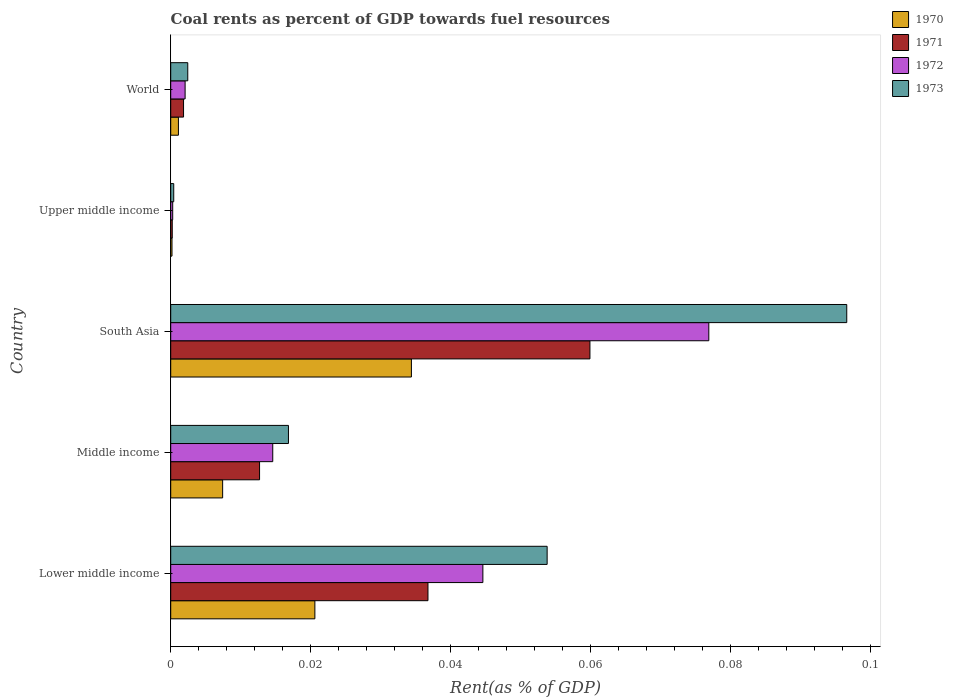How many different coloured bars are there?
Give a very brief answer. 4. Are the number of bars per tick equal to the number of legend labels?
Offer a terse response. Yes. How many bars are there on the 1st tick from the top?
Your answer should be compact. 4. How many bars are there on the 5th tick from the bottom?
Make the answer very short. 4. What is the label of the 2nd group of bars from the top?
Your answer should be compact. Upper middle income. What is the coal rent in 1970 in Upper middle income?
Make the answer very short. 0. Across all countries, what is the maximum coal rent in 1971?
Keep it short and to the point. 0.06. Across all countries, what is the minimum coal rent in 1971?
Provide a short and direct response. 0. In which country was the coal rent in 1972 minimum?
Keep it short and to the point. Upper middle income. What is the total coal rent in 1972 in the graph?
Give a very brief answer. 0.14. What is the difference between the coal rent in 1973 in Upper middle income and that in World?
Provide a short and direct response. -0. What is the difference between the coal rent in 1970 in World and the coal rent in 1971 in Upper middle income?
Keep it short and to the point. 0. What is the average coal rent in 1971 per country?
Your response must be concise. 0.02. What is the difference between the coal rent in 1973 and coal rent in 1970 in World?
Make the answer very short. 0. In how many countries, is the coal rent in 1973 greater than 0.036000000000000004 %?
Offer a very short reply. 2. What is the ratio of the coal rent in 1973 in Upper middle income to that in World?
Provide a short and direct response. 0.18. Is the difference between the coal rent in 1973 in Lower middle income and World greater than the difference between the coal rent in 1970 in Lower middle income and World?
Make the answer very short. Yes. What is the difference between the highest and the second highest coal rent in 1970?
Give a very brief answer. 0.01. What is the difference between the highest and the lowest coal rent in 1973?
Provide a succinct answer. 0.1. Is the sum of the coal rent in 1972 in South Asia and Upper middle income greater than the maximum coal rent in 1971 across all countries?
Provide a short and direct response. Yes. Is it the case that in every country, the sum of the coal rent in 1971 and coal rent in 1973 is greater than the sum of coal rent in 1970 and coal rent in 1972?
Your response must be concise. No. What does the 4th bar from the top in Upper middle income represents?
Ensure brevity in your answer.  1970. Are all the bars in the graph horizontal?
Give a very brief answer. Yes. What is the difference between two consecutive major ticks on the X-axis?
Offer a very short reply. 0.02. Are the values on the major ticks of X-axis written in scientific E-notation?
Provide a short and direct response. No. Does the graph contain any zero values?
Make the answer very short. No. Where does the legend appear in the graph?
Your answer should be very brief. Top right. How are the legend labels stacked?
Keep it short and to the point. Vertical. What is the title of the graph?
Give a very brief answer. Coal rents as percent of GDP towards fuel resources. What is the label or title of the X-axis?
Ensure brevity in your answer.  Rent(as % of GDP). What is the Rent(as % of GDP) of 1970 in Lower middle income?
Make the answer very short. 0.02. What is the Rent(as % of GDP) in 1971 in Lower middle income?
Your response must be concise. 0.04. What is the Rent(as % of GDP) of 1972 in Lower middle income?
Ensure brevity in your answer.  0.04. What is the Rent(as % of GDP) of 1973 in Lower middle income?
Your answer should be very brief. 0.05. What is the Rent(as % of GDP) of 1970 in Middle income?
Ensure brevity in your answer.  0.01. What is the Rent(as % of GDP) of 1971 in Middle income?
Give a very brief answer. 0.01. What is the Rent(as % of GDP) in 1972 in Middle income?
Give a very brief answer. 0.01. What is the Rent(as % of GDP) in 1973 in Middle income?
Your response must be concise. 0.02. What is the Rent(as % of GDP) in 1970 in South Asia?
Offer a very short reply. 0.03. What is the Rent(as % of GDP) of 1971 in South Asia?
Offer a very short reply. 0.06. What is the Rent(as % of GDP) in 1972 in South Asia?
Provide a short and direct response. 0.08. What is the Rent(as % of GDP) of 1973 in South Asia?
Your answer should be compact. 0.1. What is the Rent(as % of GDP) in 1970 in Upper middle income?
Give a very brief answer. 0. What is the Rent(as % of GDP) of 1971 in Upper middle income?
Provide a short and direct response. 0. What is the Rent(as % of GDP) in 1972 in Upper middle income?
Provide a succinct answer. 0. What is the Rent(as % of GDP) in 1973 in Upper middle income?
Provide a succinct answer. 0. What is the Rent(as % of GDP) of 1970 in World?
Ensure brevity in your answer.  0. What is the Rent(as % of GDP) of 1971 in World?
Your answer should be compact. 0. What is the Rent(as % of GDP) of 1972 in World?
Provide a short and direct response. 0. What is the Rent(as % of GDP) of 1973 in World?
Your answer should be compact. 0. Across all countries, what is the maximum Rent(as % of GDP) of 1970?
Give a very brief answer. 0.03. Across all countries, what is the maximum Rent(as % of GDP) of 1971?
Ensure brevity in your answer.  0.06. Across all countries, what is the maximum Rent(as % of GDP) in 1972?
Ensure brevity in your answer.  0.08. Across all countries, what is the maximum Rent(as % of GDP) in 1973?
Make the answer very short. 0.1. Across all countries, what is the minimum Rent(as % of GDP) in 1970?
Ensure brevity in your answer.  0. Across all countries, what is the minimum Rent(as % of GDP) in 1971?
Offer a very short reply. 0. Across all countries, what is the minimum Rent(as % of GDP) in 1972?
Keep it short and to the point. 0. Across all countries, what is the minimum Rent(as % of GDP) in 1973?
Your answer should be very brief. 0. What is the total Rent(as % of GDP) in 1970 in the graph?
Keep it short and to the point. 0.06. What is the total Rent(as % of GDP) of 1971 in the graph?
Offer a very short reply. 0.11. What is the total Rent(as % of GDP) of 1972 in the graph?
Provide a short and direct response. 0.14. What is the total Rent(as % of GDP) of 1973 in the graph?
Your answer should be compact. 0.17. What is the difference between the Rent(as % of GDP) of 1970 in Lower middle income and that in Middle income?
Make the answer very short. 0.01. What is the difference between the Rent(as % of GDP) of 1971 in Lower middle income and that in Middle income?
Provide a short and direct response. 0.02. What is the difference between the Rent(as % of GDP) of 1973 in Lower middle income and that in Middle income?
Make the answer very short. 0.04. What is the difference between the Rent(as % of GDP) in 1970 in Lower middle income and that in South Asia?
Offer a very short reply. -0.01. What is the difference between the Rent(as % of GDP) of 1971 in Lower middle income and that in South Asia?
Offer a terse response. -0.02. What is the difference between the Rent(as % of GDP) of 1972 in Lower middle income and that in South Asia?
Offer a terse response. -0.03. What is the difference between the Rent(as % of GDP) in 1973 in Lower middle income and that in South Asia?
Your answer should be compact. -0.04. What is the difference between the Rent(as % of GDP) in 1970 in Lower middle income and that in Upper middle income?
Give a very brief answer. 0.02. What is the difference between the Rent(as % of GDP) of 1971 in Lower middle income and that in Upper middle income?
Make the answer very short. 0.04. What is the difference between the Rent(as % of GDP) in 1972 in Lower middle income and that in Upper middle income?
Keep it short and to the point. 0.04. What is the difference between the Rent(as % of GDP) in 1973 in Lower middle income and that in Upper middle income?
Make the answer very short. 0.05. What is the difference between the Rent(as % of GDP) of 1970 in Lower middle income and that in World?
Ensure brevity in your answer.  0.02. What is the difference between the Rent(as % of GDP) of 1971 in Lower middle income and that in World?
Provide a short and direct response. 0.03. What is the difference between the Rent(as % of GDP) of 1972 in Lower middle income and that in World?
Your answer should be compact. 0.04. What is the difference between the Rent(as % of GDP) in 1973 in Lower middle income and that in World?
Ensure brevity in your answer.  0.05. What is the difference between the Rent(as % of GDP) of 1970 in Middle income and that in South Asia?
Ensure brevity in your answer.  -0.03. What is the difference between the Rent(as % of GDP) of 1971 in Middle income and that in South Asia?
Make the answer very short. -0.05. What is the difference between the Rent(as % of GDP) of 1972 in Middle income and that in South Asia?
Offer a very short reply. -0.06. What is the difference between the Rent(as % of GDP) of 1973 in Middle income and that in South Asia?
Offer a terse response. -0.08. What is the difference between the Rent(as % of GDP) of 1970 in Middle income and that in Upper middle income?
Your answer should be very brief. 0.01. What is the difference between the Rent(as % of GDP) of 1971 in Middle income and that in Upper middle income?
Make the answer very short. 0.01. What is the difference between the Rent(as % of GDP) in 1972 in Middle income and that in Upper middle income?
Your response must be concise. 0.01. What is the difference between the Rent(as % of GDP) of 1973 in Middle income and that in Upper middle income?
Your response must be concise. 0.02. What is the difference between the Rent(as % of GDP) in 1970 in Middle income and that in World?
Your answer should be very brief. 0.01. What is the difference between the Rent(as % of GDP) in 1971 in Middle income and that in World?
Your response must be concise. 0.01. What is the difference between the Rent(as % of GDP) in 1972 in Middle income and that in World?
Your answer should be compact. 0.01. What is the difference between the Rent(as % of GDP) of 1973 in Middle income and that in World?
Offer a very short reply. 0.01. What is the difference between the Rent(as % of GDP) in 1970 in South Asia and that in Upper middle income?
Give a very brief answer. 0.03. What is the difference between the Rent(as % of GDP) in 1971 in South Asia and that in Upper middle income?
Offer a very short reply. 0.06. What is the difference between the Rent(as % of GDP) in 1972 in South Asia and that in Upper middle income?
Your response must be concise. 0.08. What is the difference between the Rent(as % of GDP) in 1973 in South Asia and that in Upper middle income?
Your answer should be compact. 0.1. What is the difference between the Rent(as % of GDP) in 1971 in South Asia and that in World?
Your response must be concise. 0.06. What is the difference between the Rent(as % of GDP) of 1972 in South Asia and that in World?
Ensure brevity in your answer.  0.07. What is the difference between the Rent(as % of GDP) in 1973 in South Asia and that in World?
Your answer should be very brief. 0.09. What is the difference between the Rent(as % of GDP) of 1970 in Upper middle income and that in World?
Give a very brief answer. -0. What is the difference between the Rent(as % of GDP) in 1971 in Upper middle income and that in World?
Your answer should be very brief. -0. What is the difference between the Rent(as % of GDP) of 1972 in Upper middle income and that in World?
Your answer should be very brief. -0. What is the difference between the Rent(as % of GDP) of 1973 in Upper middle income and that in World?
Provide a succinct answer. -0. What is the difference between the Rent(as % of GDP) in 1970 in Lower middle income and the Rent(as % of GDP) in 1971 in Middle income?
Offer a terse response. 0.01. What is the difference between the Rent(as % of GDP) of 1970 in Lower middle income and the Rent(as % of GDP) of 1972 in Middle income?
Your response must be concise. 0.01. What is the difference between the Rent(as % of GDP) of 1970 in Lower middle income and the Rent(as % of GDP) of 1973 in Middle income?
Offer a terse response. 0. What is the difference between the Rent(as % of GDP) of 1971 in Lower middle income and the Rent(as % of GDP) of 1972 in Middle income?
Offer a very short reply. 0.02. What is the difference between the Rent(as % of GDP) in 1971 in Lower middle income and the Rent(as % of GDP) in 1973 in Middle income?
Provide a short and direct response. 0.02. What is the difference between the Rent(as % of GDP) in 1972 in Lower middle income and the Rent(as % of GDP) in 1973 in Middle income?
Keep it short and to the point. 0.03. What is the difference between the Rent(as % of GDP) in 1970 in Lower middle income and the Rent(as % of GDP) in 1971 in South Asia?
Offer a very short reply. -0.04. What is the difference between the Rent(as % of GDP) in 1970 in Lower middle income and the Rent(as % of GDP) in 1972 in South Asia?
Ensure brevity in your answer.  -0.06. What is the difference between the Rent(as % of GDP) in 1970 in Lower middle income and the Rent(as % of GDP) in 1973 in South Asia?
Offer a terse response. -0.08. What is the difference between the Rent(as % of GDP) in 1971 in Lower middle income and the Rent(as % of GDP) in 1972 in South Asia?
Ensure brevity in your answer.  -0.04. What is the difference between the Rent(as % of GDP) of 1971 in Lower middle income and the Rent(as % of GDP) of 1973 in South Asia?
Make the answer very short. -0.06. What is the difference between the Rent(as % of GDP) of 1972 in Lower middle income and the Rent(as % of GDP) of 1973 in South Asia?
Your answer should be very brief. -0.05. What is the difference between the Rent(as % of GDP) in 1970 in Lower middle income and the Rent(as % of GDP) in 1971 in Upper middle income?
Make the answer very short. 0.02. What is the difference between the Rent(as % of GDP) of 1970 in Lower middle income and the Rent(as % of GDP) of 1972 in Upper middle income?
Ensure brevity in your answer.  0.02. What is the difference between the Rent(as % of GDP) of 1970 in Lower middle income and the Rent(as % of GDP) of 1973 in Upper middle income?
Your answer should be very brief. 0.02. What is the difference between the Rent(as % of GDP) of 1971 in Lower middle income and the Rent(as % of GDP) of 1972 in Upper middle income?
Provide a short and direct response. 0.04. What is the difference between the Rent(as % of GDP) in 1971 in Lower middle income and the Rent(as % of GDP) in 1973 in Upper middle income?
Offer a very short reply. 0.04. What is the difference between the Rent(as % of GDP) of 1972 in Lower middle income and the Rent(as % of GDP) of 1973 in Upper middle income?
Offer a very short reply. 0.04. What is the difference between the Rent(as % of GDP) in 1970 in Lower middle income and the Rent(as % of GDP) in 1971 in World?
Provide a short and direct response. 0.02. What is the difference between the Rent(as % of GDP) in 1970 in Lower middle income and the Rent(as % of GDP) in 1972 in World?
Your response must be concise. 0.02. What is the difference between the Rent(as % of GDP) of 1970 in Lower middle income and the Rent(as % of GDP) of 1973 in World?
Your response must be concise. 0.02. What is the difference between the Rent(as % of GDP) of 1971 in Lower middle income and the Rent(as % of GDP) of 1972 in World?
Provide a succinct answer. 0.03. What is the difference between the Rent(as % of GDP) of 1971 in Lower middle income and the Rent(as % of GDP) of 1973 in World?
Your response must be concise. 0.03. What is the difference between the Rent(as % of GDP) in 1972 in Lower middle income and the Rent(as % of GDP) in 1973 in World?
Provide a short and direct response. 0.04. What is the difference between the Rent(as % of GDP) of 1970 in Middle income and the Rent(as % of GDP) of 1971 in South Asia?
Offer a terse response. -0.05. What is the difference between the Rent(as % of GDP) in 1970 in Middle income and the Rent(as % of GDP) in 1972 in South Asia?
Your answer should be compact. -0.07. What is the difference between the Rent(as % of GDP) of 1970 in Middle income and the Rent(as % of GDP) of 1973 in South Asia?
Your answer should be very brief. -0.09. What is the difference between the Rent(as % of GDP) in 1971 in Middle income and the Rent(as % of GDP) in 1972 in South Asia?
Your answer should be compact. -0.06. What is the difference between the Rent(as % of GDP) of 1971 in Middle income and the Rent(as % of GDP) of 1973 in South Asia?
Your answer should be compact. -0.08. What is the difference between the Rent(as % of GDP) of 1972 in Middle income and the Rent(as % of GDP) of 1973 in South Asia?
Make the answer very short. -0.08. What is the difference between the Rent(as % of GDP) of 1970 in Middle income and the Rent(as % of GDP) of 1971 in Upper middle income?
Your answer should be very brief. 0.01. What is the difference between the Rent(as % of GDP) of 1970 in Middle income and the Rent(as % of GDP) of 1972 in Upper middle income?
Keep it short and to the point. 0.01. What is the difference between the Rent(as % of GDP) of 1970 in Middle income and the Rent(as % of GDP) of 1973 in Upper middle income?
Your answer should be compact. 0.01. What is the difference between the Rent(as % of GDP) of 1971 in Middle income and the Rent(as % of GDP) of 1972 in Upper middle income?
Offer a terse response. 0.01. What is the difference between the Rent(as % of GDP) in 1971 in Middle income and the Rent(as % of GDP) in 1973 in Upper middle income?
Your response must be concise. 0.01. What is the difference between the Rent(as % of GDP) of 1972 in Middle income and the Rent(as % of GDP) of 1973 in Upper middle income?
Your answer should be very brief. 0.01. What is the difference between the Rent(as % of GDP) in 1970 in Middle income and the Rent(as % of GDP) in 1971 in World?
Keep it short and to the point. 0.01. What is the difference between the Rent(as % of GDP) in 1970 in Middle income and the Rent(as % of GDP) in 1972 in World?
Your response must be concise. 0.01. What is the difference between the Rent(as % of GDP) of 1970 in Middle income and the Rent(as % of GDP) of 1973 in World?
Ensure brevity in your answer.  0.01. What is the difference between the Rent(as % of GDP) of 1971 in Middle income and the Rent(as % of GDP) of 1972 in World?
Your answer should be very brief. 0.01. What is the difference between the Rent(as % of GDP) in 1971 in Middle income and the Rent(as % of GDP) in 1973 in World?
Your answer should be compact. 0.01. What is the difference between the Rent(as % of GDP) of 1972 in Middle income and the Rent(as % of GDP) of 1973 in World?
Your answer should be compact. 0.01. What is the difference between the Rent(as % of GDP) in 1970 in South Asia and the Rent(as % of GDP) in 1971 in Upper middle income?
Your response must be concise. 0.03. What is the difference between the Rent(as % of GDP) in 1970 in South Asia and the Rent(as % of GDP) in 1972 in Upper middle income?
Offer a very short reply. 0.03. What is the difference between the Rent(as % of GDP) of 1970 in South Asia and the Rent(as % of GDP) of 1973 in Upper middle income?
Make the answer very short. 0.03. What is the difference between the Rent(as % of GDP) in 1971 in South Asia and the Rent(as % of GDP) in 1972 in Upper middle income?
Offer a terse response. 0.06. What is the difference between the Rent(as % of GDP) in 1971 in South Asia and the Rent(as % of GDP) in 1973 in Upper middle income?
Make the answer very short. 0.06. What is the difference between the Rent(as % of GDP) of 1972 in South Asia and the Rent(as % of GDP) of 1973 in Upper middle income?
Offer a terse response. 0.08. What is the difference between the Rent(as % of GDP) in 1970 in South Asia and the Rent(as % of GDP) in 1971 in World?
Keep it short and to the point. 0.03. What is the difference between the Rent(as % of GDP) of 1970 in South Asia and the Rent(as % of GDP) of 1972 in World?
Offer a very short reply. 0.03. What is the difference between the Rent(as % of GDP) in 1970 in South Asia and the Rent(as % of GDP) in 1973 in World?
Your response must be concise. 0.03. What is the difference between the Rent(as % of GDP) in 1971 in South Asia and the Rent(as % of GDP) in 1972 in World?
Make the answer very short. 0.06. What is the difference between the Rent(as % of GDP) in 1971 in South Asia and the Rent(as % of GDP) in 1973 in World?
Offer a terse response. 0.06. What is the difference between the Rent(as % of GDP) of 1972 in South Asia and the Rent(as % of GDP) of 1973 in World?
Your response must be concise. 0.07. What is the difference between the Rent(as % of GDP) in 1970 in Upper middle income and the Rent(as % of GDP) in 1971 in World?
Your response must be concise. -0. What is the difference between the Rent(as % of GDP) of 1970 in Upper middle income and the Rent(as % of GDP) of 1972 in World?
Keep it short and to the point. -0. What is the difference between the Rent(as % of GDP) of 1970 in Upper middle income and the Rent(as % of GDP) of 1973 in World?
Your answer should be compact. -0. What is the difference between the Rent(as % of GDP) of 1971 in Upper middle income and the Rent(as % of GDP) of 1972 in World?
Provide a succinct answer. -0. What is the difference between the Rent(as % of GDP) in 1971 in Upper middle income and the Rent(as % of GDP) in 1973 in World?
Provide a succinct answer. -0. What is the difference between the Rent(as % of GDP) of 1972 in Upper middle income and the Rent(as % of GDP) of 1973 in World?
Give a very brief answer. -0. What is the average Rent(as % of GDP) in 1970 per country?
Keep it short and to the point. 0.01. What is the average Rent(as % of GDP) of 1971 per country?
Provide a succinct answer. 0.02. What is the average Rent(as % of GDP) of 1972 per country?
Offer a terse response. 0.03. What is the average Rent(as % of GDP) in 1973 per country?
Make the answer very short. 0.03. What is the difference between the Rent(as % of GDP) in 1970 and Rent(as % of GDP) in 1971 in Lower middle income?
Your response must be concise. -0.02. What is the difference between the Rent(as % of GDP) of 1970 and Rent(as % of GDP) of 1972 in Lower middle income?
Offer a very short reply. -0.02. What is the difference between the Rent(as % of GDP) of 1970 and Rent(as % of GDP) of 1973 in Lower middle income?
Provide a short and direct response. -0.03. What is the difference between the Rent(as % of GDP) of 1971 and Rent(as % of GDP) of 1972 in Lower middle income?
Your response must be concise. -0.01. What is the difference between the Rent(as % of GDP) in 1971 and Rent(as % of GDP) in 1973 in Lower middle income?
Give a very brief answer. -0.02. What is the difference between the Rent(as % of GDP) of 1972 and Rent(as % of GDP) of 1973 in Lower middle income?
Offer a terse response. -0.01. What is the difference between the Rent(as % of GDP) of 1970 and Rent(as % of GDP) of 1971 in Middle income?
Provide a succinct answer. -0.01. What is the difference between the Rent(as % of GDP) of 1970 and Rent(as % of GDP) of 1972 in Middle income?
Keep it short and to the point. -0.01. What is the difference between the Rent(as % of GDP) of 1970 and Rent(as % of GDP) of 1973 in Middle income?
Give a very brief answer. -0.01. What is the difference between the Rent(as % of GDP) in 1971 and Rent(as % of GDP) in 1972 in Middle income?
Offer a terse response. -0. What is the difference between the Rent(as % of GDP) in 1971 and Rent(as % of GDP) in 1973 in Middle income?
Your response must be concise. -0. What is the difference between the Rent(as % of GDP) of 1972 and Rent(as % of GDP) of 1973 in Middle income?
Ensure brevity in your answer.  -0. What is the difference between the Rent(as % of GDP) of 1970 and Rent(as % of GDP) of 1971 in South Asia?
Offer a terse response. -0.03. What is the difference between the Rent(as % of GDP) in 1970 and Rent(as % of GDP) in 1972 in South Asia?
Your answer should be compact. -0.04. What is the difference between the Rent(as % of GDP) of 1970 and Rent(as % of GDP) of 1973 in South Asia?
Provide a short and direct response. -0.06. What is the difference between the Rent(as % of GDP) of 1971 and Rent(as % of GDP) of 1972 in South Asia?
Give a very brief answer. -0.02. What is the difference between the Rent(as % of GDP) in 1971 and Rent(as % of GDP) in 1973 in South Asia?
Give a very brief answer. -0.04. What is the difference between the Rent(as % of GDP) in 1972 and Rent(as % of GDP) in 1973 in South Asia?
Ensure brevity in your answer.  -0.02. What is the difference between the Rent(as % of GDP) of 1970 and Rent(as % of GDP) of 1972 in Upper middle income?
Provide a succinct answer. -0. What is the difference between the Rent(as % of GDP) in 1970 and Rent(as % of GDP) in 1973 in Upper middle income?
Your answer should be very brief. -0. What is the difference between the Rent(as % of GDP) in 1971 and Rent(as % of GDP) in 1972 in Upper middle income?
Keep it short and to the point. -0. What is the difference between the Rent(as % of GDP) in 1971 and Rent(as % of GDP) in 1973 in Upper middle income?
Provide a short and direct response. -0. What is the difference between the Rent(as % of GDP) of 1972 and Rent(as % of GDP) of 1973 in Upper middle income?
Your response must be concise. -0. What is the difference between the Rent(as % of GDP) of 1970 and Rent(as % of GDP) of 1971 in World?
Provide a short and direct response. -0. What is the difference between the Rent(as % of GDP) of 1970 and Rent(as % of GDP) of 1972 in World?
Provide a succinct answer. -0. What is the difference between the Rent(as % of GDP) of 1970 and Rent(as % of GDP) of 1973 in World?
Offer a very short reply. -0. What is the difference between the Rent(as % of GDP) in 1971 and Rent(as % of GDP) in 1972 in World?
Provide a short and direct response. -0. What is the difference between the Rent(as % of GDP) of 1971 and Rent(as % of GDP) of 1973 in World?
Make the answer very short. -0. What is the difference between the Rent(as % of GDP) in 1972 and Rent(as % of GDP) in 1973 in World?
Offer a very short reply. -0. What is the ratio of the Rent(as % of GDP) of 1970 in Lower middle income to that in Middle income?
Your response must be concise. 2.78. What is the ratio of the Rent(as % of GDP) of 1971 in Lower middle income to that in Middle income?
Provide a succinct answer. 2.9. What is the ratio of the Rent(as % of GDP) of 1972 in Lower middle income to that in Middle income?
Provide a short and direct response. 3.06. What is the ratio of the Rent(as % of GDP) of 1973 in Lower middle income to that in Middle income?
Keep it short and to the point. 3.2. What is the ratio of the Rent(as % of GDP) of 1970 in Lower middle income to that in South Asia?
Give a very brief answer. 0.6. What is the ratio of the Rent(as % of GDP) of 1971 in Lower middle income to that in South Asia?
Keep it short and to the point. 0.61. What is the ratio of the Rent(as % of GDP) in 1972 in Lower middle income to that in South Asia?
Offer a very short reply. 0.58. What is the ratio of the Rent(as % of GDP) in 1973 in Lower middle income to that in South Asia?
Provide a succinct answer. 0.56. What is the ratio of the Rent(as % of GDP) in 1970 in Lower middle income to that in Upper middle income?
Your answer should be compact. 112.03. What is the ratio of the Rent(as % of GDP) in 1971 in Lower middle income to that in Upper middle income?
Make the answer very short. 167.98. What is the ratio of the Rent(as % of GDP) of 1972 in Lower middle income to that in Upper middle income?
Keep it short and to the point. 156.82. What is the ratio of the Rent(as % of GDP) of 1973 in Lower middle income to that in Upper middle income?
Ensure brevity in your answer.  124.82. What is the ratio of the Rent(as % of GDP) of 1970 in Lower middle income to that in World?
Your answer should be very brief. 18.71. What is the ratio of the Rent(as % of GDP) of 1971 in Lower middle income to that in World?
Provide a succinct answer. 20.06. What is the ratio of the Rent(as % of GDP) in 1972 in Lower middle income to that in World?
Make the answer very short. 21.7. What is the ratio of the Rent(as % of GDP) of 1973 in Lower middle income to that in World?
Offer a terse response. 22.07. What is the ratio of the Rent(as % of GDP) in 1970 in Middle income to that in South Asia?
Give a very brief answer. 0.22. What is the ratio of the Rent(as % of GDP) in 1971 in Middle income to that in South Asia?
Offer a very short reply. 0.21. What is the ratio of the Rent(as % of GDP) in 1972 in Middle income to that in South Asia?
Offer a very short reply. 0.19. What is the ratio of the Rent(as % of GDP) in 1973 in Middle income to that in South Asia?
Your answer should be compact. 0.17. What is the ratio of the Rent(as % of GDP) in 1970 in Middle income to that in Upper middle income?
Provide a short and direct response. 40.36. What is the ratio of the Rent(as % of GDP) in 1971 in Middle income to that in Upper middle income?
Your answer should be very brief. 58.01. What is the ratio of the Rent(as % of GDP) of 1972 in Middle income to that in Upper middle income?
Offer a very short reply. 51.25. What is the ratio of the Rent(as % of GDP) of 1973 in Middle income to that in Upper middle income?
Your answer should be very brief. 39.04. What is the ratio of the Rent(as % of GDP) in 1970 in Middle income to that in World?
Your answer should be compact. 6.74. What is the ratio of the Rent(as % of GDP) in 1971 in Middle income to that in World?
Give a very brief answer. 6.93. What is the ratio of the Rent(as % of GDP) of 1972 in Middle income to that in World?
Make the answer very short. 7.09. What is the ratio of the Rent(as % of GDP) of 1973 in Middle income to that in World?
Your response must be concise. 6.91. What is the ratio of the Rent(as % of GDP) in 1970 in South Asia to that in Upper middle income?
Keep it short and to the point. 187.05. What is the ratio of the Rent(as % of GDP) in 1971 in South Asia to that in Upper middle income?
Your response must be concise. 273.74. What is the ratio of the Rent(as % of GDP) in 1972 in South Asia to that in Upper middle income?
Your response must be concise. 270.32. What is the ratio of the Rent(as % of GDP) in 1973 in South Asia to that in Upper middle income?
Ensure brevity in your answer.  224.18. What is the ratio of the Rent(as % of GDP) of 1970 in South Asia to that in World?
Provide a short and direct response. 31.24. What is the ratio of the Rent(as % of GDP) of 1971 in South Asia to that in World?
Your answer should be very brief. 32.69. What is the ratio of the Rent(as % of GDP) in 1972 in South Asia to that in World?
Your answer should be very brief. 37.41. What is the ratio of the Rent(as % of GDP) of 1973 in South Asia to that in World?
Keep it short and to the point. 39.65. What is the ratio of the Rent(as % of GDP) in 1970 in Upper middle income to that in World?
Your answer should be compact. 0.17. What is the ratio of the Rent(as % of GDP) of 1971 in Upper middle income to that in World?
Provide a short and direct response. 0.12. What is the ratio of the Rent(as % of GDP) in 1972 in Upper middle income to that in World?
Provide a short and direct response. 0.14. What is the ratio of the Rent(as % of GDP) in 1973 in Upper middle income to that in World?
Offer a very short reply. 0.18. What is the difference between the highest and the second highest Rent(as % of GDP) in 1970?
Give a very brief answer. 0.01. What is the difference between the highest and the second highest Rent(as % of GDP) of 1971?
Give a very brief answer. 0.02. What is the difference between the highest and the second highest Rent(as % of GDP) in 1972?
Make the answer very short. 0.03. What is the difference between the highest and the second highest Rent(as % of GDP) of 1973?
Your answer should be very brief. 0.04. What is the difference between the highest and the lowest Rent(as % of GDP) of 1970?
Make the answer very short. 0.03. What is the difference between the highest and the lowest Rent(as % of GDP) of 1971?
Your answer should be very brief. 0.06. What is the difference between the highest and the lowest Rent(as % of GDP) in 1972?
Your answer should be very brief. 0.08. What is the difference between the highest and the lowest Rent(as % of GDP) of 1973?
Offer a terse response. 0.1. 